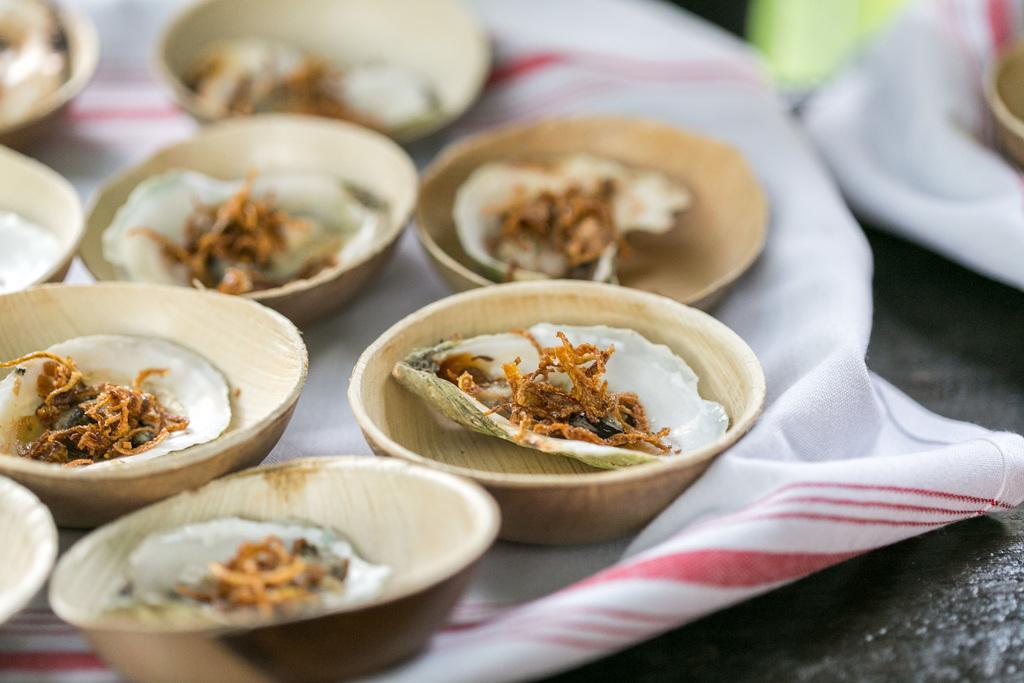How would you summarize this image in a sentence or two? In this image we can see some food items in the cups, which are on the cloth, and the background is blurred. 